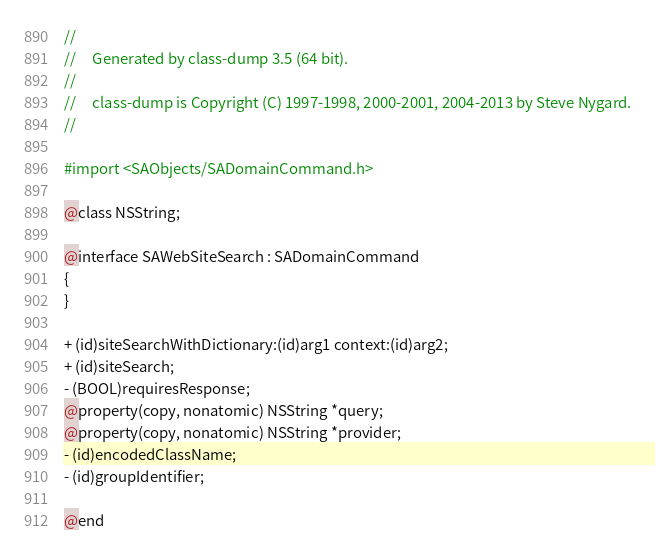<code> <loc_0><loc_0><loc_500><loc_500><_C_>//
//     Generated by class-dump 3.5 (64 bit).
//
//     class-dump is Copyright (C) 1997-1998, 2000-2001, 2004-2013 by Steve Nygard.
//

#import <SAObjects/SADomainCommand.h>

@class NSString;

@interface SAWebSiteSearch : SADomainCommand
{
}

+ (id)siteSearchWithDictionary:(id)arg1 context:(id)arg2;
+ (id)siteSearch;
- (BOOL)requiresResponse;
@property(copy, nonatomic) NSString *query;
@property(copy, nonatomic) NSString *provider;
- (id)encodedClassName;
- (id)groupIdentifier;

@end

</code> 